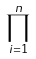Convert formula to latex. <formula><loc_0><loc_0><loc_500><loc_500>\prod _ { i = 1 } ^ { n }</formula> 